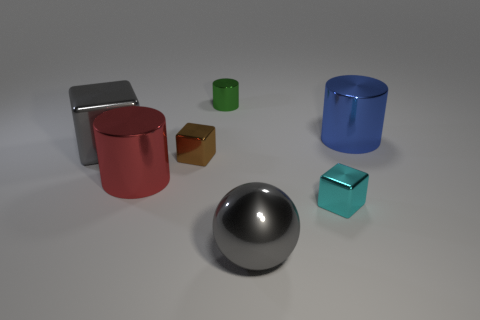There is a big blue object that is made of the same material as the large gray ball; what shape is it?
Keep it short and to the point. Cylinder. What number of tiny metallic cylinders are there?
Provide a short and direct response. 1. Is the shape of the small metal object behind the blue thing the same as  the big red thing?
Provide a succinct answer. Yes. There is a cyan object that is the same size as the green thing; what material is it?
Your answer should be compact. Metal. Is there a brown cube made of the same material as the cyan thing?
Your answer should be very brief. Yes. Does the blue object have the same shape as the gray metallic object that is left of the red object?
Give a very brief answer. No. How many metallic objects are on the left side of the cyan object and in front of the large red metallic object?
Your answer should be very brief. 1. Are the cyan object and the big gray thing in front of the red object made of the same material?
Give a very brief answer. Yes. Are there an equal number of brown shiny cubes that are in front of the red metallic cylinder and blue metallic cylinders?
Keep it short and to the point. No. What is the color of the object that is in front of the cyan metal cube?
Offer a terse response. Gray. 